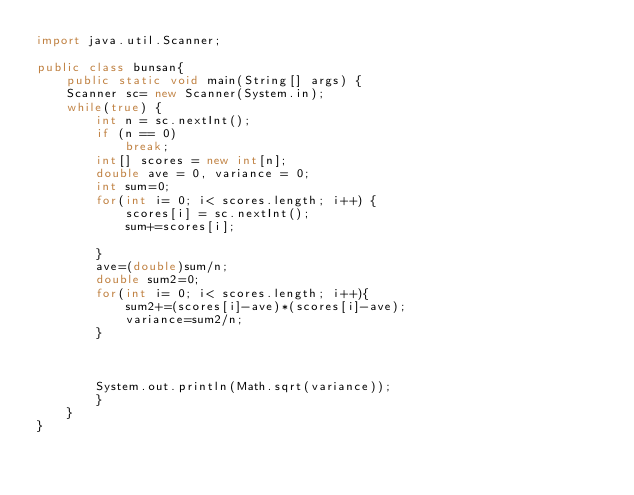<code> <loc_0><loc_0><loc_500><loc_500><_Java_>import java.util.Scanner;

public class bunsan{
	public static void main(String[] args) {
	Scanner sc= new Scanner(System.in);
	while(true) {
		int n = sc.nextInt();
		if (n == 0) 
			break;
		int[] scores = new int[n];
		double ave = 0, variance = 0;
		int sum=0;
		for(int i= 0; i< scores.length; i++) {
			scores[i] = sc.nextInt();
			sum+=scores[i];	
			
		}
		ave=(double)sum/n;
		double sum2=0;
		for(int i= 0; i< scores.length; i++){
			sum2+=(scores[i]-ave)*(scores[i]-ave);
			variance=sum2/n;
		}

		
		
		System.out.println(Math.sqrt(variance));
		}
	}
}</code> 